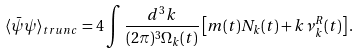<formula> <loc_0><loc_0><loc_500><loc_500>\langle \bar { \psi } \psi \rangle _ { t r u n c } = 4 \int \frac { d ^ { 3 } k } { ( 2 \pi ) ^ { 3 } \Omega _ { k } ( t ) } \left [ m ( t ) N _ { k } ( t ) + k \nu _ { k } ^ { R } ( t ) \right ] .</formula> 